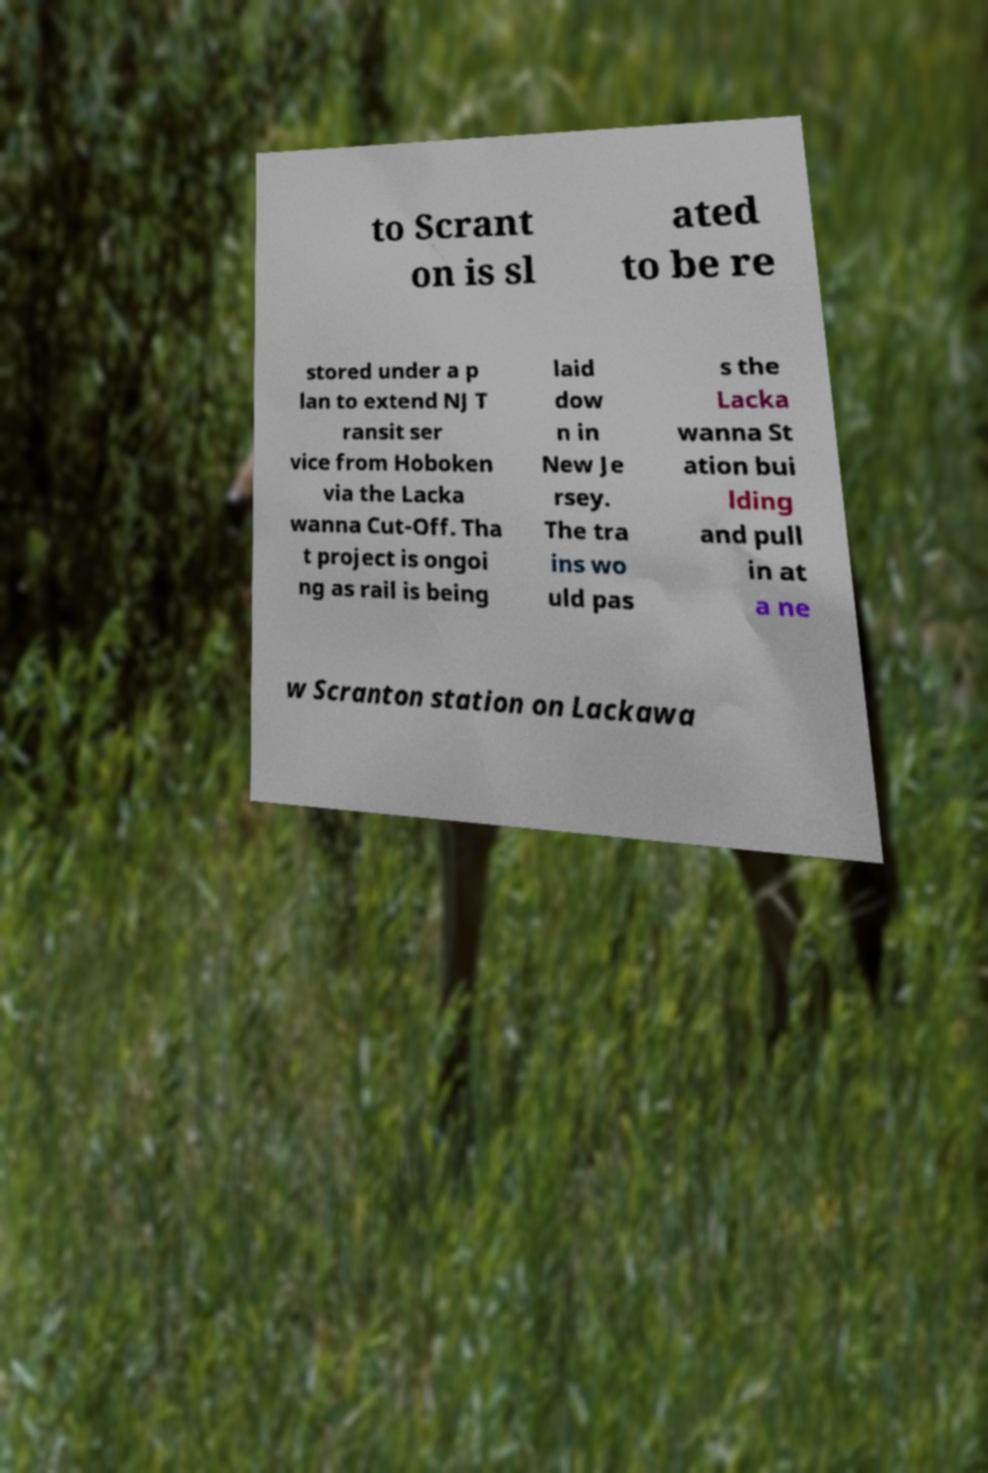Please identify and transcribe the text found in this image. to Scrant on is sl ated to be re stored under a p lan to extend NJ T ransit ser vice from Hoboken via the Lacka wanna Cut-Off. Tha t project is ongoi ng as rail is being laid dow n in New Je rsey. The tra ins wo uld pas s the Lacka wanna St ation bui lding and pull in at a ne w Scranton station on Lackawa 